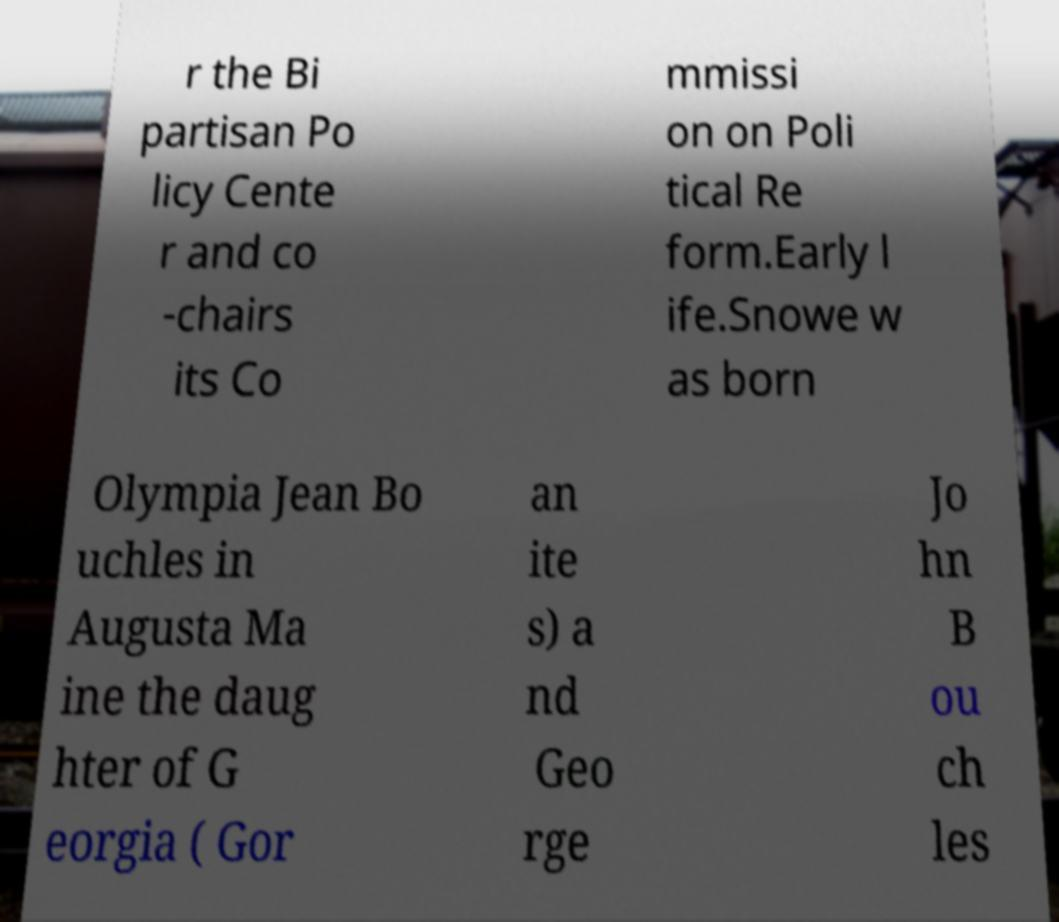Can you accurately transcribe the text from the provided image for me? r the Bi partisan Po licy Cente r and co -chairs its Co mmissi on on Poli tical Re form.Early l ife.Snowe w as born Olympia Jean Bo uchles in Augusta Ma ine the daug hter of G eorgia ( Gor an ite s) a nd Geo rge Jo hn B ou ch les 